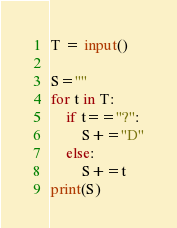Convert code to text. <code><loc_0><loc_0><loc_500><loc_500><_Python_>T = input()

S=""
for t in T:
    if t=="?":
        S+="D"
    else:
        S+=t
print(S)
</code> 